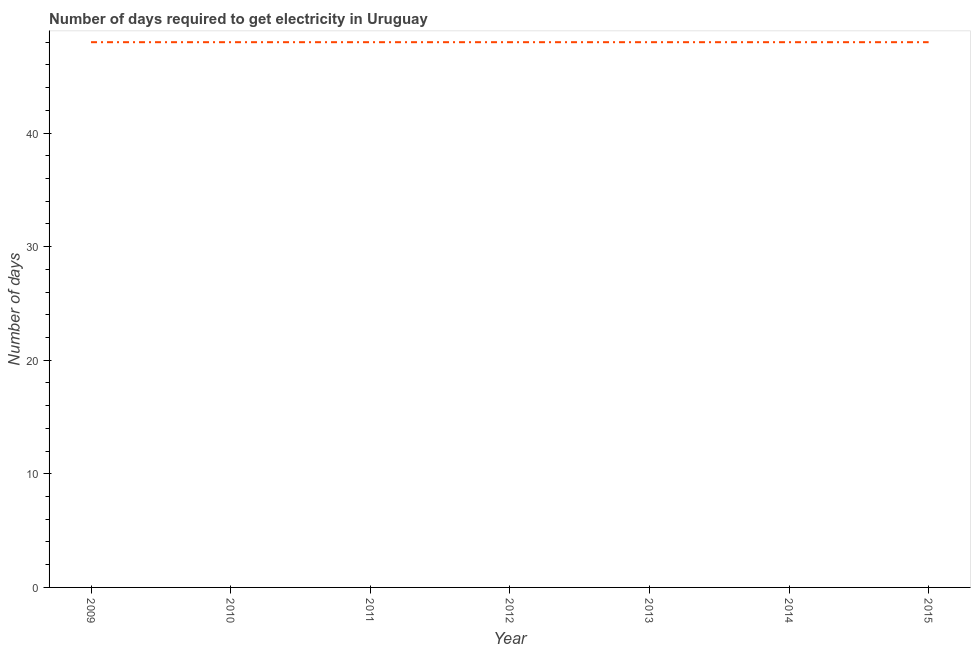What is the time to get electricity in 2013?
Your answer should be very brief. 48. Across all years, what is the maximum time to get electricity?
Make the answer very short. 48. Across all years, what is the minimum time to get electricity?
Offer a terse response. 48. In which year was the time to get electricity maximum?
Your answer should be compact. 2009. In which year was the time to get electricity minimum?
Offer a terse response. 2009. What is the sum of the time to get electricity?
Your response must be concise. 336. What is the difference between the time to get electricity in 2009 and 2013?
Provide a short and direct response. 0. What is the ratio of the time to get electricity in 2010 to that in 2015?
Your response must be concise. 1. Is the time to get electricity in 2009 less than that in 2012?
Provide a short and direct response. No. Is the difference between the time to get electricity in 2009 and 2010 greater than the difference between any two years?
Make the answer very short. Yes. What is the difference between the highest and the second highest time to get electricity?
Your response must be concise. 0. Is the sum of the time to get electricity in 2009 and 2013 greater than the maximum time to get electricity across all years?
Offer a very short reply. Yes. Does the time to get electricity monotonically increase over the years?
Keep it short and to the point. No. How many lines are there?
Provide a short and direct response. 1. Does the graph contain any zero values?
Provide a succinct answer. No. Does the graph contain grids?
Keep it short and to the point. No. What is the title of the graph?
Give a very brief answer. Number of days required to get electricity in Uruguay. What is the label or title of the X-axis?
Your answer should be very brief. Year. What is the label or title of the Y-axis?
Provide a short and direct response. Number of days. What is the Number of days in 2013?
Provide a succinct answer. 48. What is the Number of days in 2014?
Ensure brevity in your answer.  48. What is the Number of days of 2015?
Your answer should be compact. 48. What is the difference between the Number of days in 2010 and 2012?
Your answer should be compact. 0. What is the difference between the Number of days in 2010 and 2013?
Your answer should be very brief. 0. What is the difference between the Number of days in 2011 and 2012?
Your answer should be very brief. 0. What is the difference between the Number of days in 2011 and 2014?
Ensure brevity in your answer.  0. What is the difference between the Number of days in 2012 and 2013?
Offer a terse response. 0. What is the difference between the Number of days in 2012 and 2015?
Provide a succinct answer. 0. What is the difference between the Number of days in 2013 and 2015?
Offer a very short reply. 0. What is the difference between the Number of days in 2014 and 2015?
Give a very brief answer. 0. What is the ratio of the Number of days in 2009 to that in 2012?
Give a very brief answer. 1. What is the ratio of the Number of days in 2009 to that in 2014?
Provide a succinct answer. 1. What is the ratio of the Number of days in 2009 to that in 2015?
Offer a very short reply. 1. What is the ratio of the Number of days in 2010 to that in 2013?
Your answer should be compact. 1. What is the ratio of the Number of days in 2010 to that in 2015?
Provide a short and direct response. 1. What is the ratio of the Number of days in 2011 to that in 2013?
Provide a succinct answer. 1. What is the ratio of the Number of days in 2011 to that in 2014?
Keep it short and to the point. 1. What is the ratio of the Number of days in 2012 to that in 2013?
Make the answer very short. 1. What is the ratio of the Number of days in 2012 to that in 2014?
Give a very brief answer. 1. What is the ratio of the Number of days in 2012 to that in 2015?
Offer a very short reply. 1. What is the ratio of the Number of days in 2013 to that in 2015?
Ensure brevity in your answer.  1. 